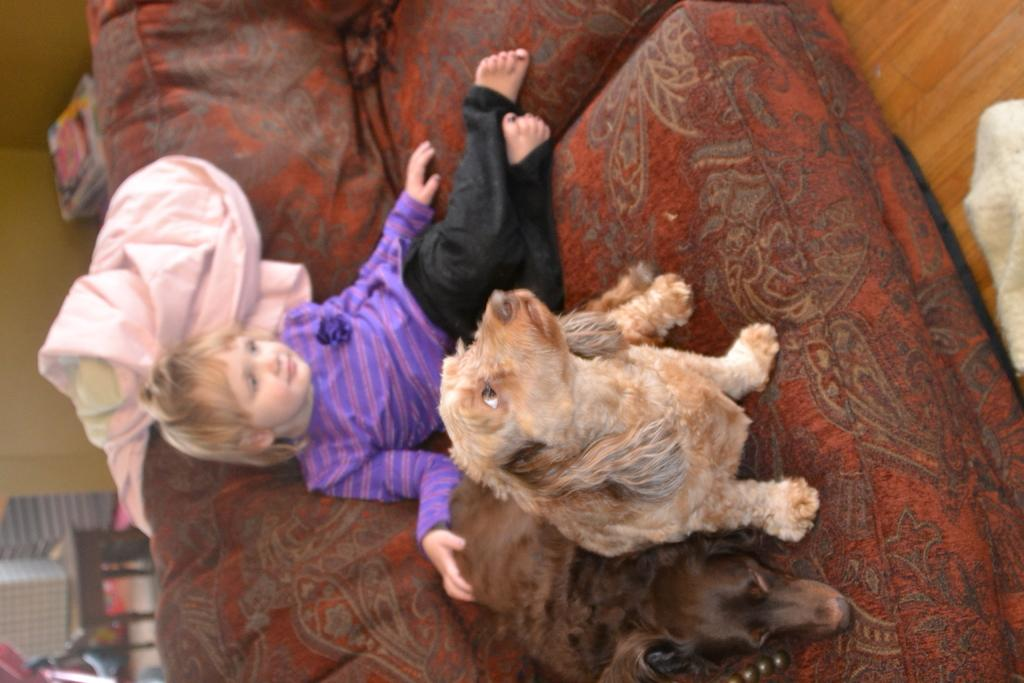What is present in the image that is not a person or animal? There is a cloth in the image. Who is present in the image? There is a girl in the image. How many dogs are in the image? There are two dogs in the image. Where are the girl and dogs located in the image? The girl and dogs are on a sofa. What type of loss is being experienced by the girl in the image? There is no indication of loss in the image; it features a girl and two dogs on a sofa. 